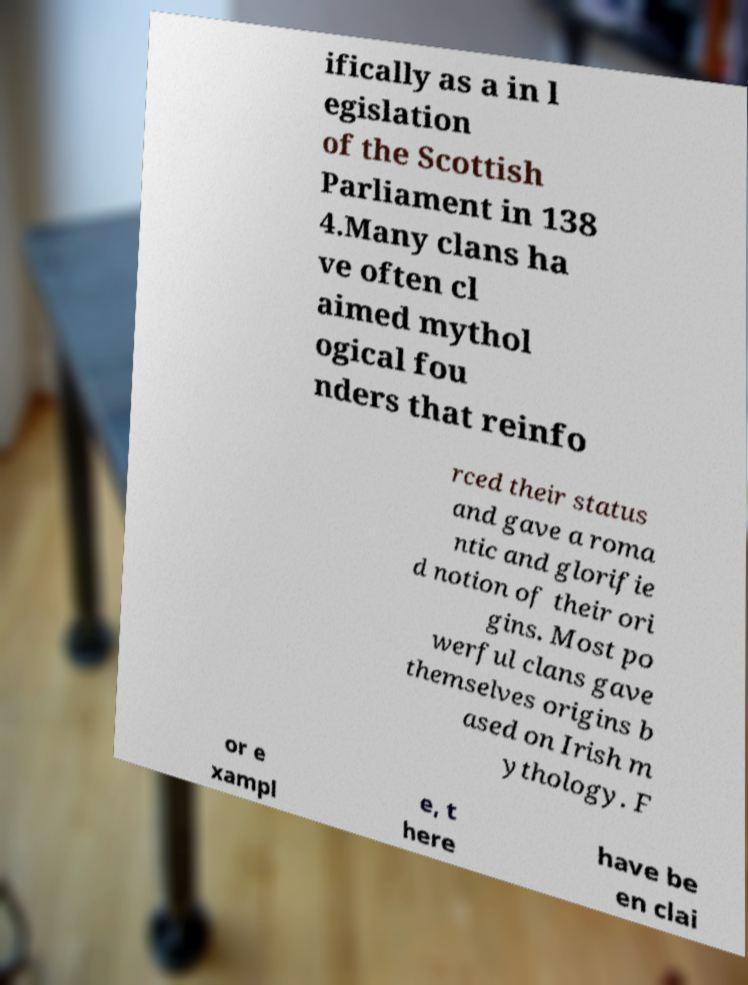Can you accurately transcribe the text from the provided image for me? ifically as a in l egislation of the Scottish Parliament in 138 4.Many clans ha ve often cl aimed mythol ogical fou nders that reinfo rced their status and gave a roma ntic and glorifie d notion of their ori gins. Most po werful clans gave themselves origins b ased on Irish m ythology. F or e xampl e, t here have be en clai 